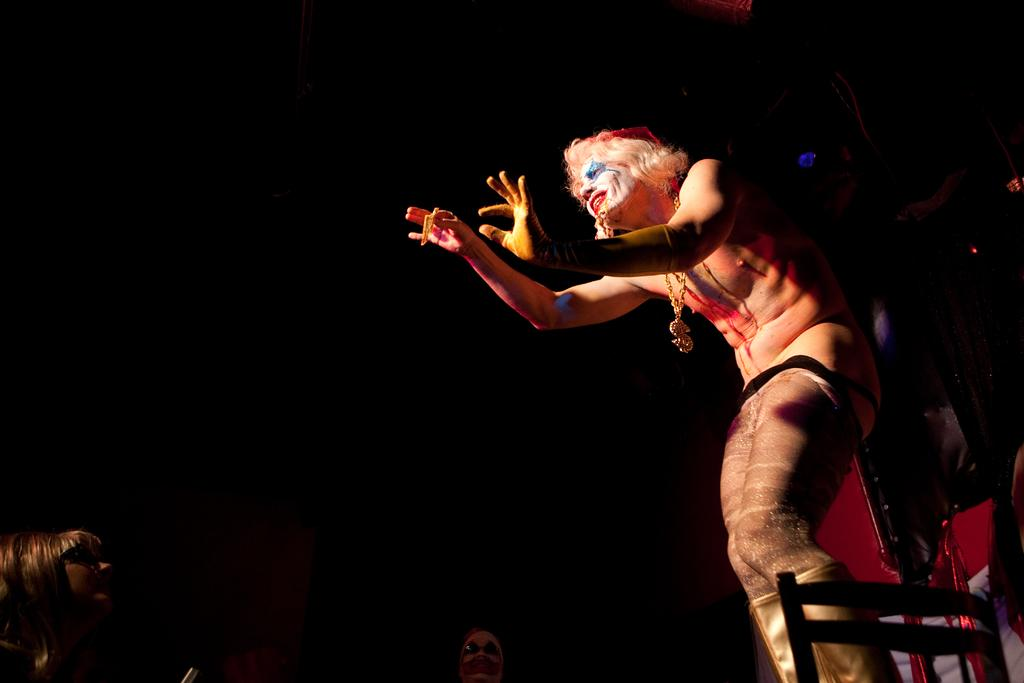How many people are in the image? There are three people in the image. What else can be seen in the image besides the people? There are objects visible in the image. What is the color of the background in the image? The background of the image is black. What type of stitch is being used to sew the linen in the image? There is no linen or stitching present in the image. What type of desk can be seen in the image? There is no desk present in the image. 